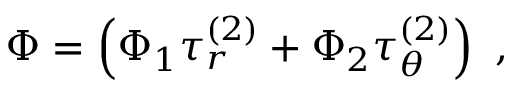<formula> <loc_0><loc_0><loc_500><loc_500>\Phi = \left ( \Phi _ { 1 } \tau _ { r } ^ { ( 2 ) } + \Phi _ { 2 } \tau _ { \theta } ^ { ( 2 ) } \right ) \ ,</formula> 